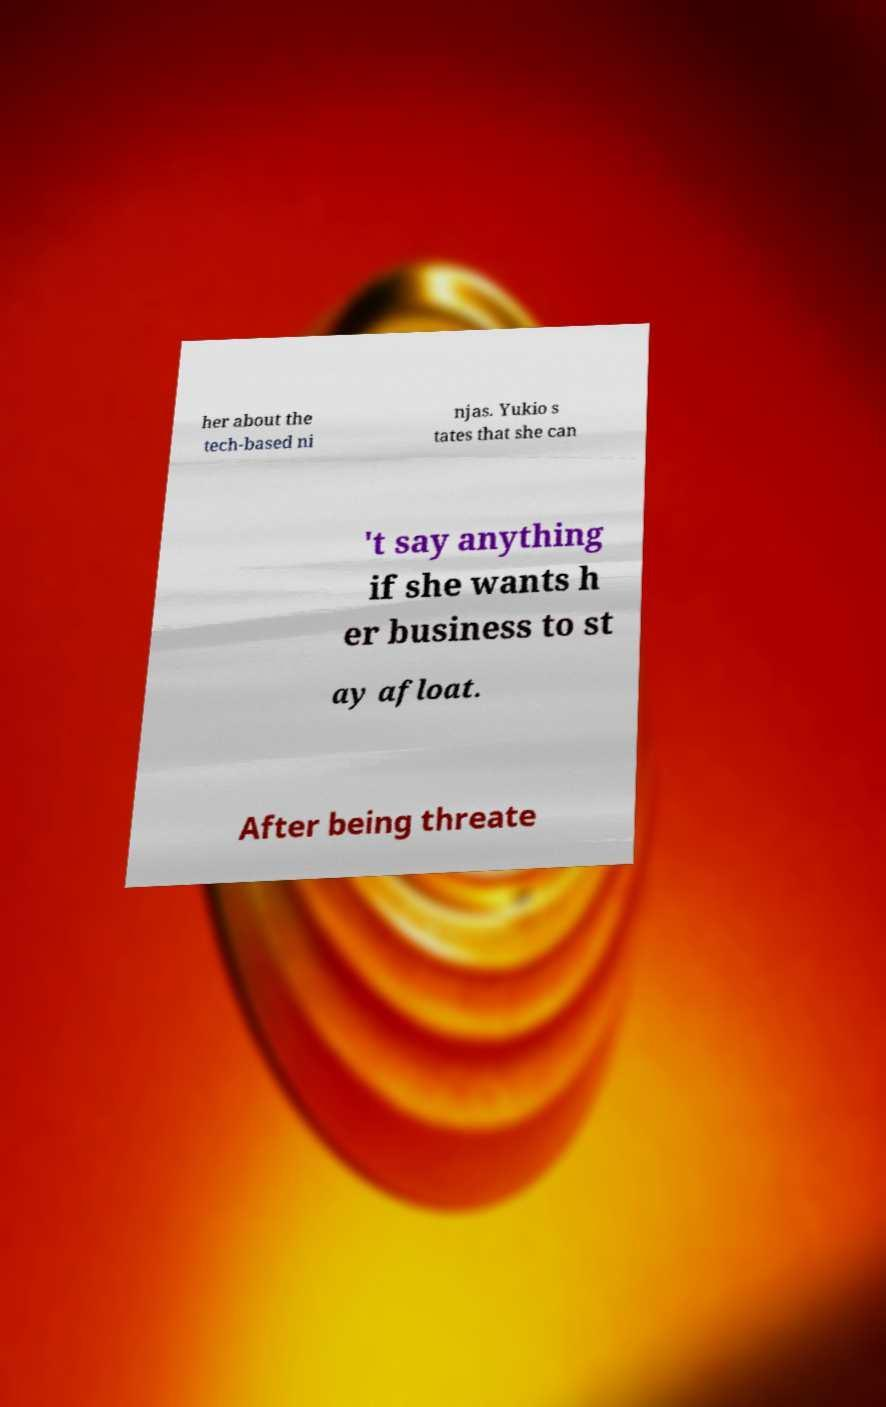What messages or text are displayed in this image? I need them in a readable, typed format. her about the tech-based ni njas. Yukio s tates that she can 't say anything if she wants h er business to st ay afloat. After being threate 